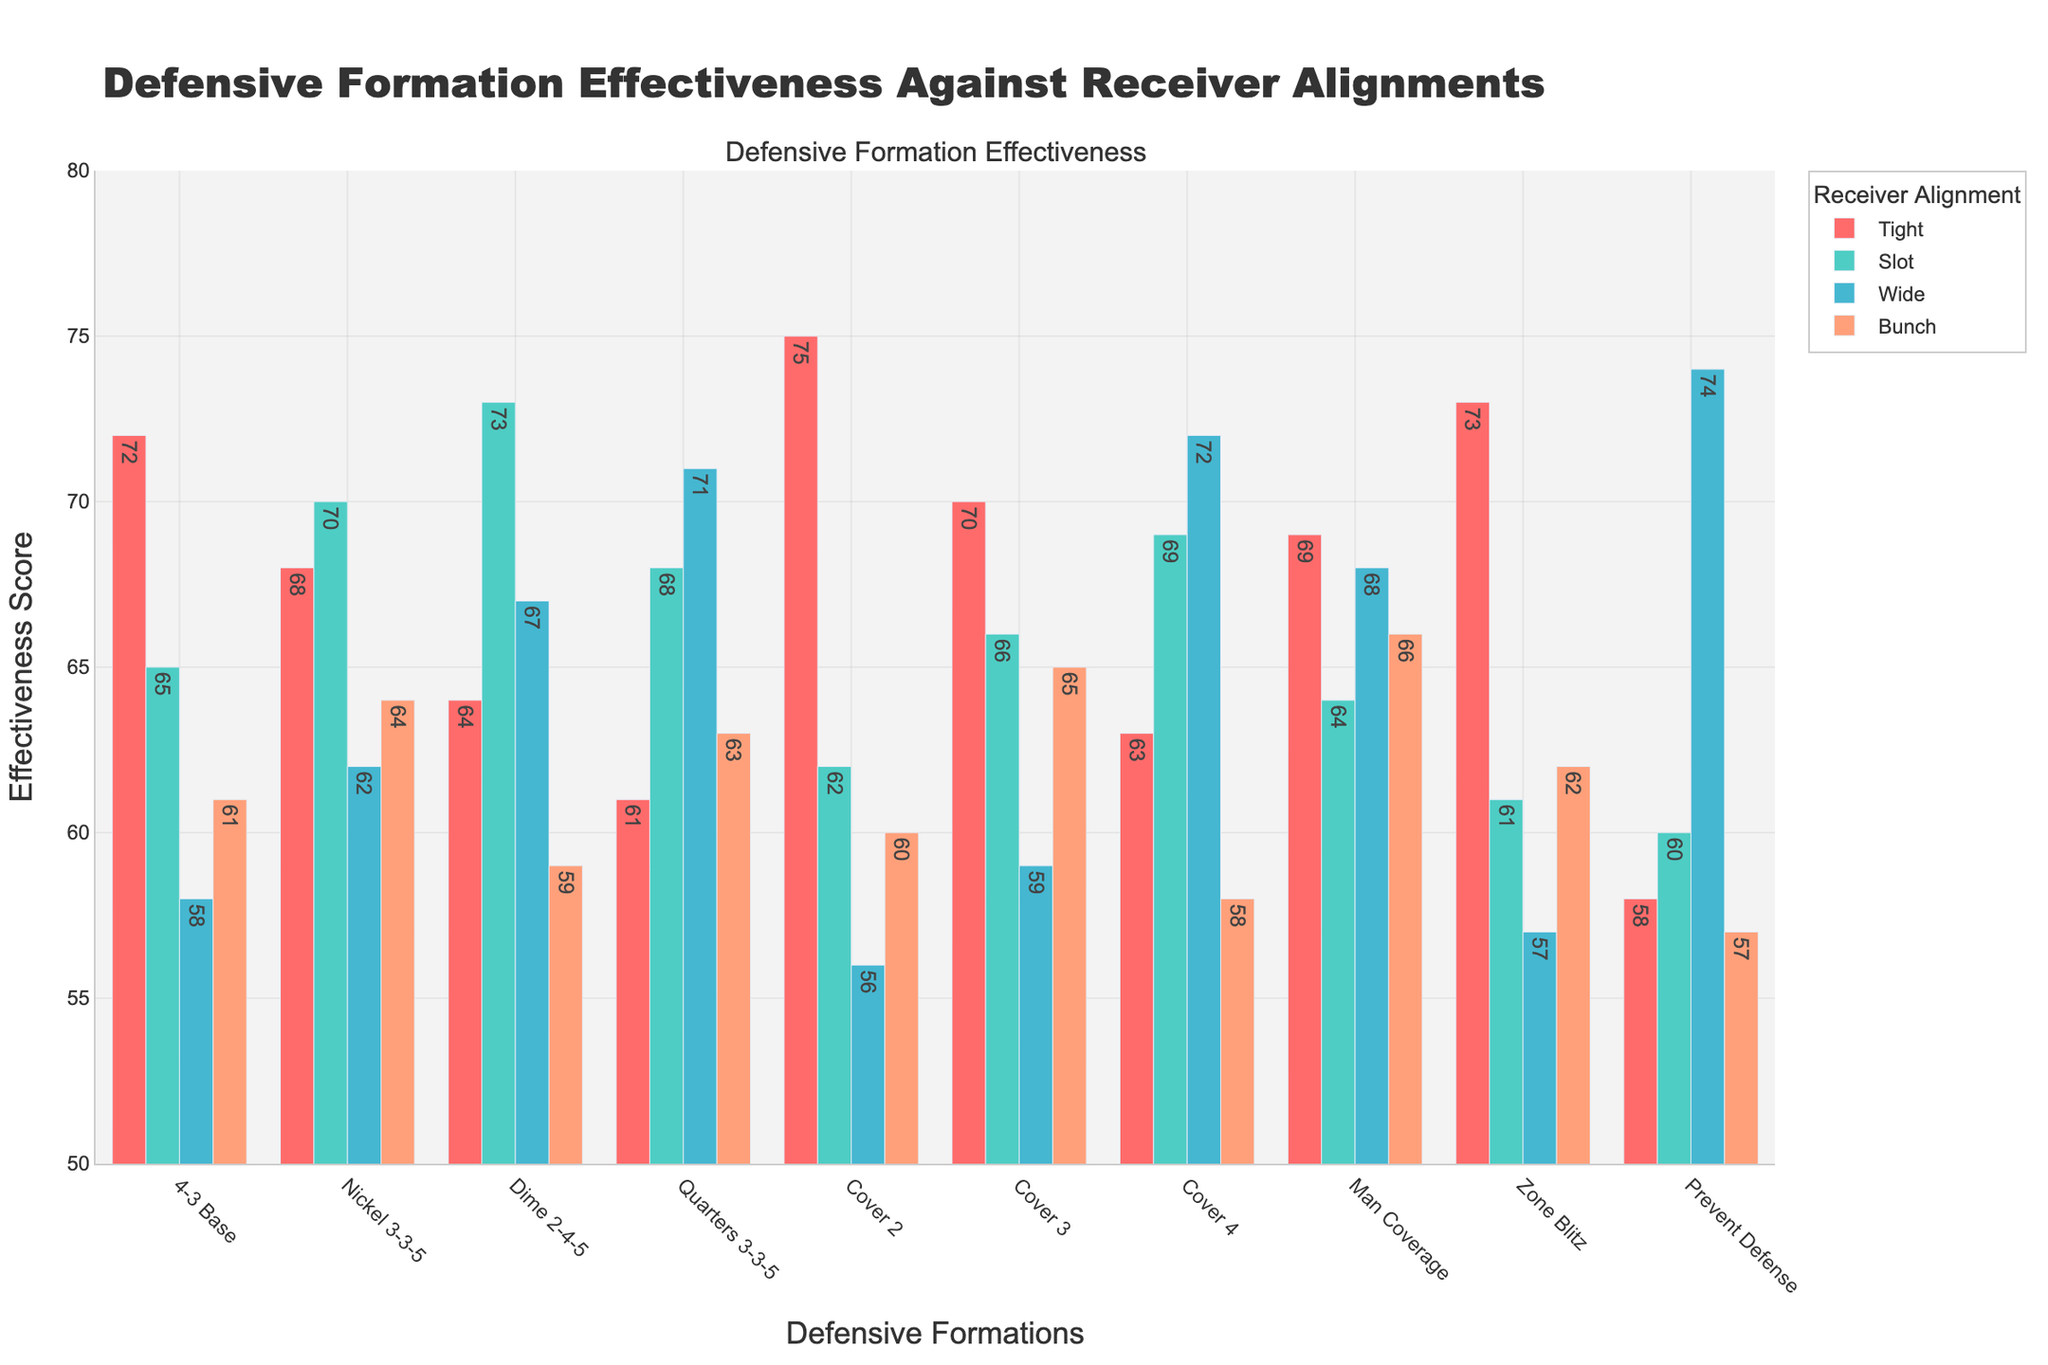What's the most effective defensive formation against receivers aligned wide? To find the most effective formation against wide-aligned receivers, look at the bar heights for the "Wide" category. The formation with the highest score is the most effective. Here, "Prevent Defense" scores 74, which is the highest.
Answer: Prevent Defense Which defensive formation is least effective against tight receiver alignment? Compare the bars under the "Tight" category and identify the lowest one. "Prevent Defense" has the lowest score with 58.
Answer: Prevent Defense How does Man Coverage compare to Cover 2 against bunch formations? Check the heights of the bars for Man Coverage and Cover 2 under the "Bunch" category. Man Coverage has a score of 66, while Cover 2 has a score of 60. Man Coverage is more effective.
Answer: Man Coverage is more effective What is the average effectiveness score of Nickel 3-3-5 across all receiver alignments? Sum the effectiveness scores of Nickel 3-3-5 for all alignments (68+70+62+64) and divide by the number of alignments (4). (68+70+62+64) / 4 = 264 / 4 = 66
Answer: 66 Which defensive formation has the smallest range of effectiveness scores across all alignments? Calculate the range (maximum value - minimum value) for each formation across the alignments. The formation with the smallest range is the one with the least difference between its highest and lowest scores. Quarters 3-3-5 has scores ranging from 61 to 71 (difference of 10).
Answer: Quarters 3-3-5 In which alignment is Dime 2-4-5 more effective than Cover 3? For each alignment, compare the scores of Dime 2-4-5 and Cover 3. Dime 2-4-5 scores higher than Cover 3 in the Slot, Wide, and Bunch alignments.
Answer: Slot, Wide, and Bunch What is the combined effectiveness score of the 4-3 Base formation against Slot and Bunch alignments? Add the effectiveness scores of the 4-3 Base formation for Slot and Bunch alignments (65 + 61). 65 + 61 = 126
Answer: 126 Which alignment shows the highest variability in defensive effectiveness across all formations? To assess variability, look at the range of effectiveness scores for each alignment. "Wide" alignment has scores ranging from 56 to 74, showing the highest variability.
Answer: Wide What’s the most and least effective formation against slot alignment? Check the heights of the bars in the "Slot" category. The most effective formation is "Dime 2-4-5" with a score of 73, and the least effective is "Zone Blitz" with a score of 61.
Answer: Most: Dime 2-4-5, Least: Zone Blitz 